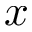Convert formula to latex. <formula><loc_0><loc_0><loc_500><loc_500>x</formula> 